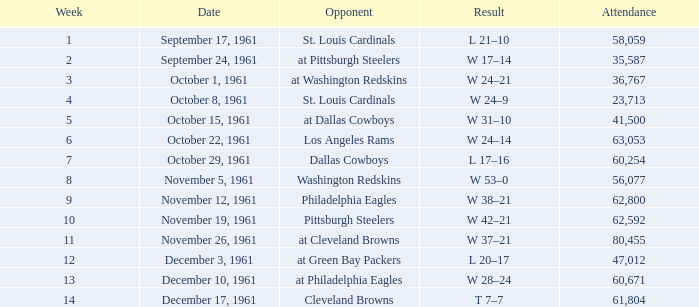What occurred on october 8, 1961? W 24–9. 